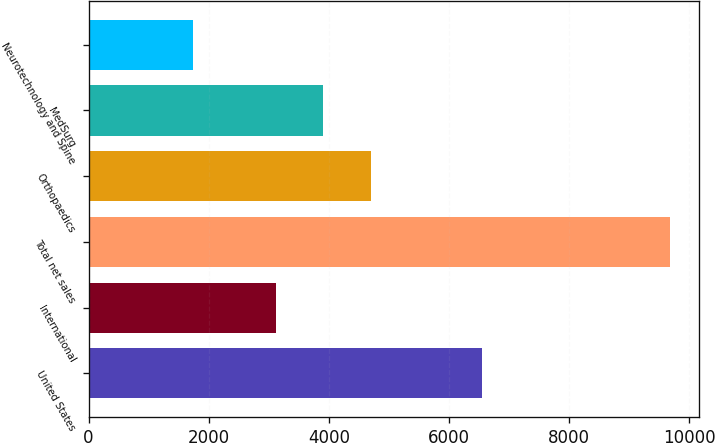Convert chart. <chart><loc_0><loc_0><loc_500><loc_500><bar_chart><fcel>United States<fcel>International<fcel>Total net sales<fcel>Orthopaedics<fcel>MedSurg<fcel>Neurotechnology and Spine<nl><fcel>6558<fcel>3117<fcel>9675<fcel>4703.8<fcel>3910.4<fcel>1741<nl></chart> 